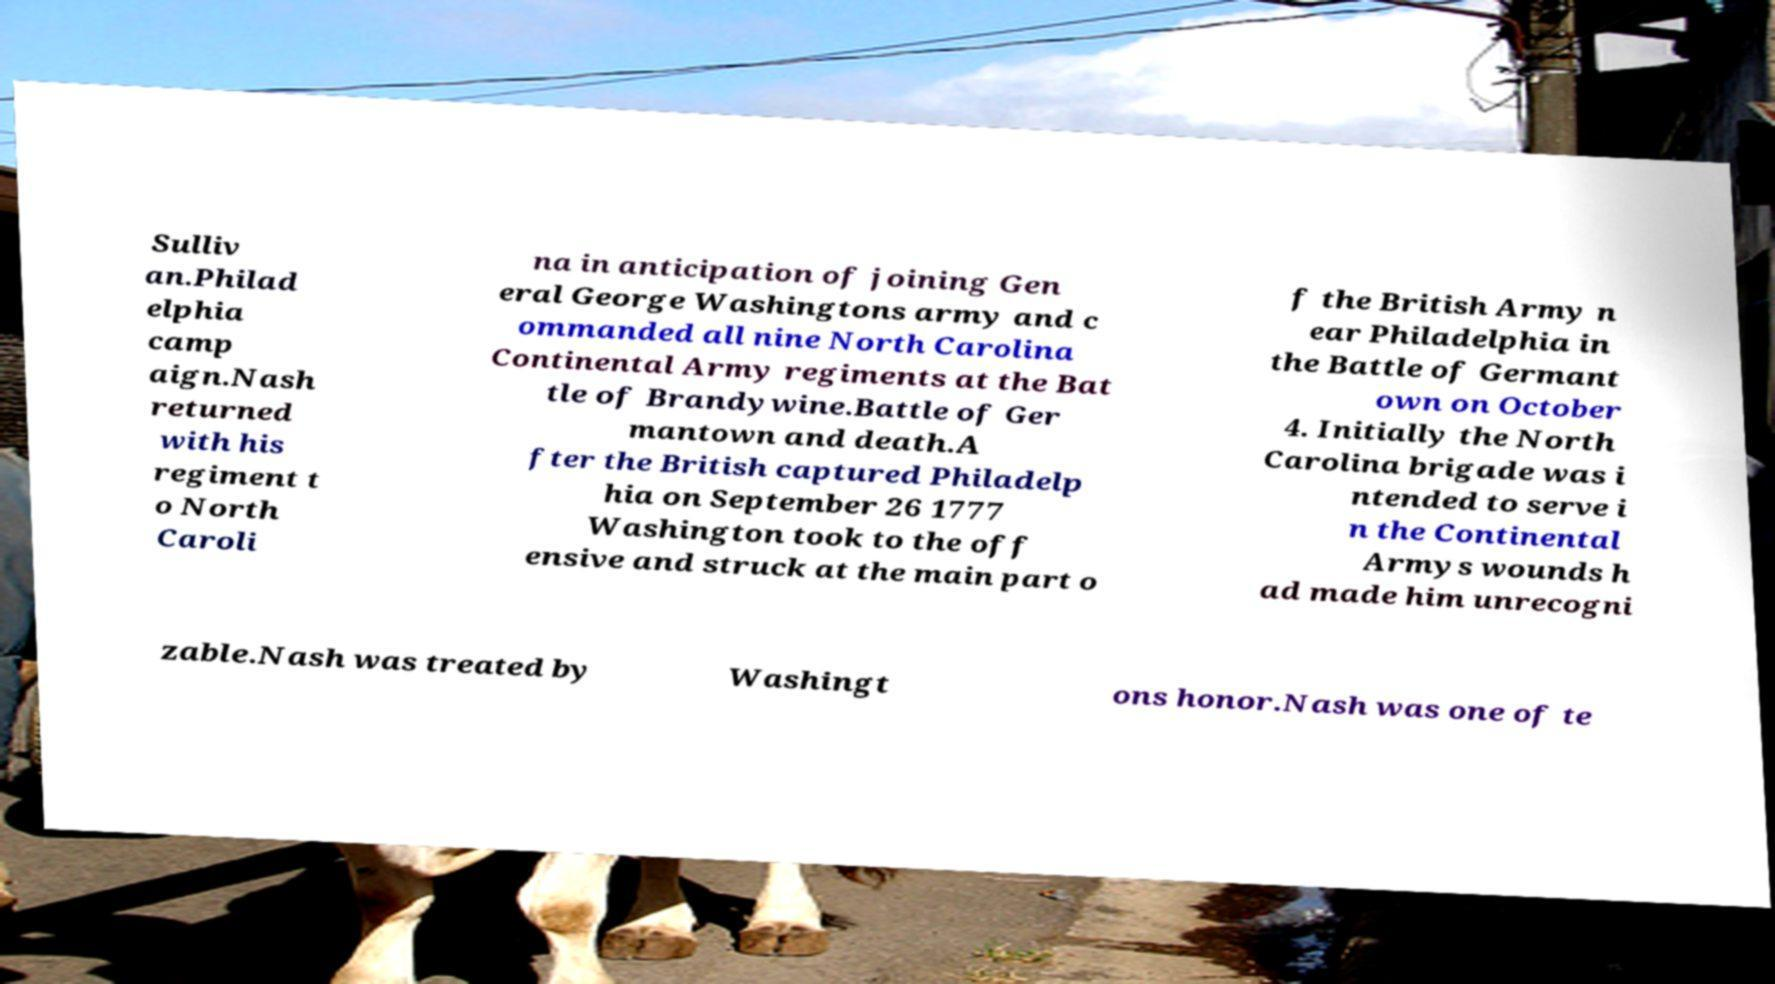Can you accurately transcribe the text from the provided image for me? Sulliv an.Philad elphia camp aign.Nash returned with his regiment t o North Caroli na in anticipation of joining Gen eral George Washingtons army and c ommanded all nine North Carolina Continental Army regiments at the Bat tle of Brandywine.Battle of Ger mantown and death.A fter the British captured Philadelp hia on September 26 1777 Washington took to the off ensive and struck at the main part o f the British Army n ear Philadelphia in the Battle of Germant own on October 4. Initially the North Carolina brigade was i ntended to serve i n the Continental Armys wounds h ad made him unrecogni zable.Nash was treated by Washingt ons honor.Nash was one of te 